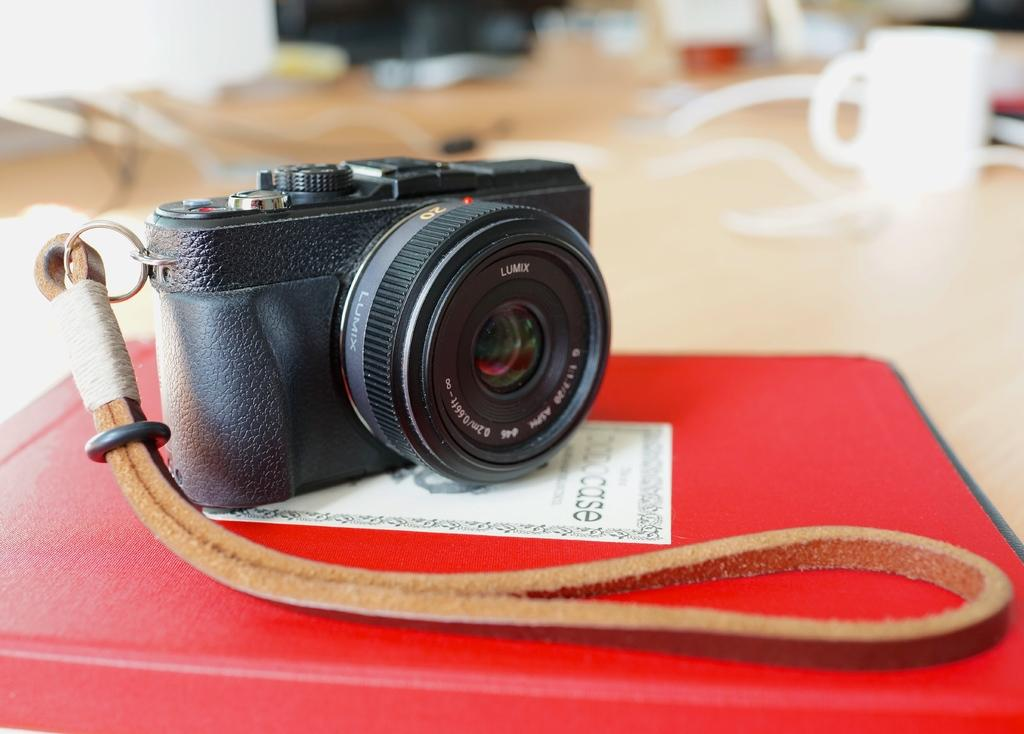What object is placed on the book file holder in the image? There is a camera on a book file holder in the image. What other object can be seen in the image? There is a cup on the top right side of the image. What type of pet is visible in the image? There is no pet present in the image. What occasion is being celebrated in the image? There is no indication of a birthday or any celebration in the image. 